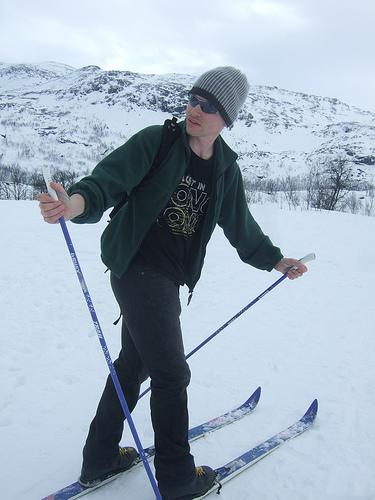Question: what is on the ground?
Choices:
A. Gravel.
B. Snow.
C. Grass.
D. Sand.
Answer with the letter. Answer: B Question: what is temperature like in the photo?
Choices:
A. Cold.
B. Hot.
C. Moderate.
D. Unable to tell.
Answer with the letter. Answer: A Question: what is the man doing?
Choices:
A. Skiing.
B. Snowboarding.
C. Windsurfing.
D. Surfing.
Answer with the letter. Answer: A Question: what equipment is in the photo?
Choices:
A. Snowboards.
B. Surfboards.
C. Windsurfers.
D. Skis.
Answer with the letter. Answer: D Question: when was the picture taken of the man?
Choices:
A. Nighttime.
B. Sunset.
C. Sunrise.
D. Daytime.
Answer with the letter. Answer: D Question: where was the picture taken?
Choices:
A. Beach.
B. Desert.
C. Mountain.
D. Zoo.
Answer with the letter. Answer: C 